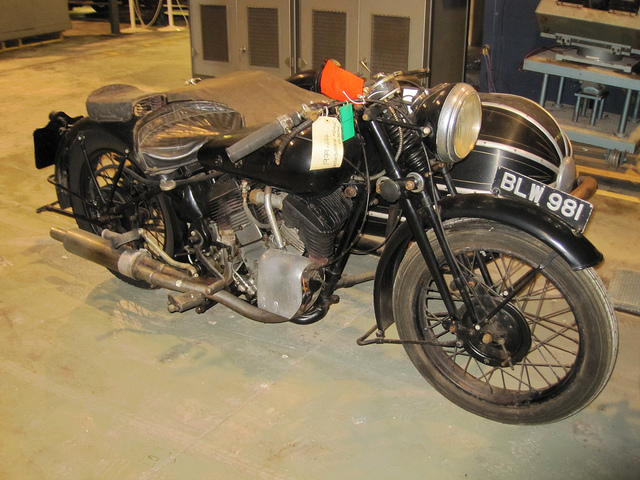Read all the text in this image. 981 BLW 